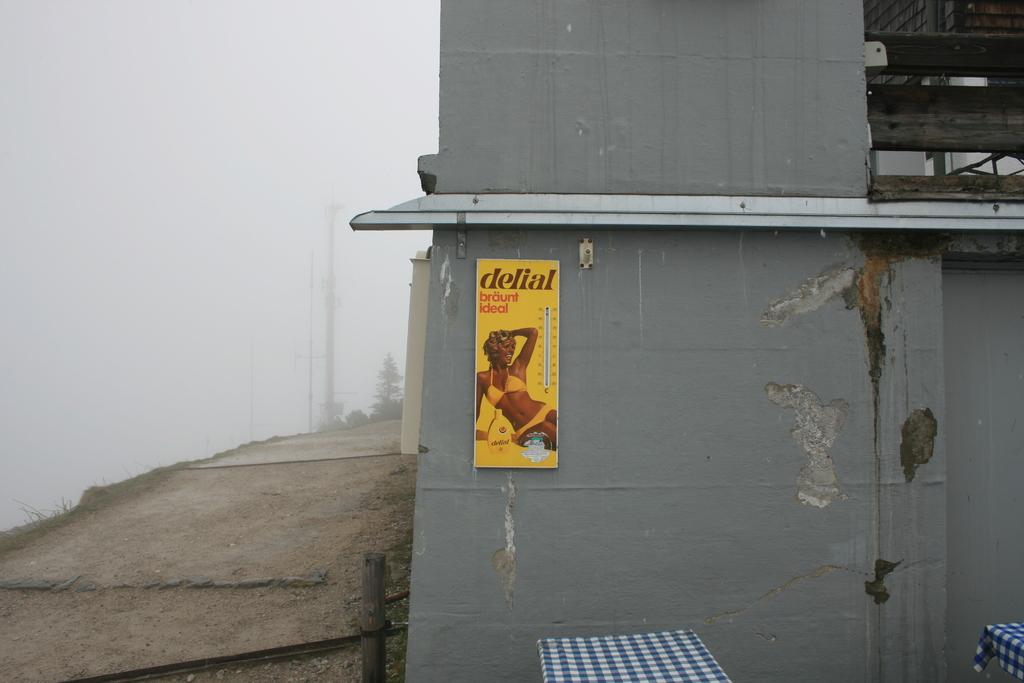What is located on the right side of the image in the foreground? There is a wall in the foreground on the right side of the image. What is on the wall? There is a poster on the wall. How many tables can be seen in the image? There are two tables in the image. What is on the left side of the image? There is a path on the left side of the image. What can be seen in the sky in the image? The sky is visible in the image and appears to be foggy. What type of flowers are growing on the zinc in the image? There are no flowers or zinc present in the image. What statement is written on the poster in the image? The provided facts do not mention any specific statement on the poster, only that there is a poster on the wall. 